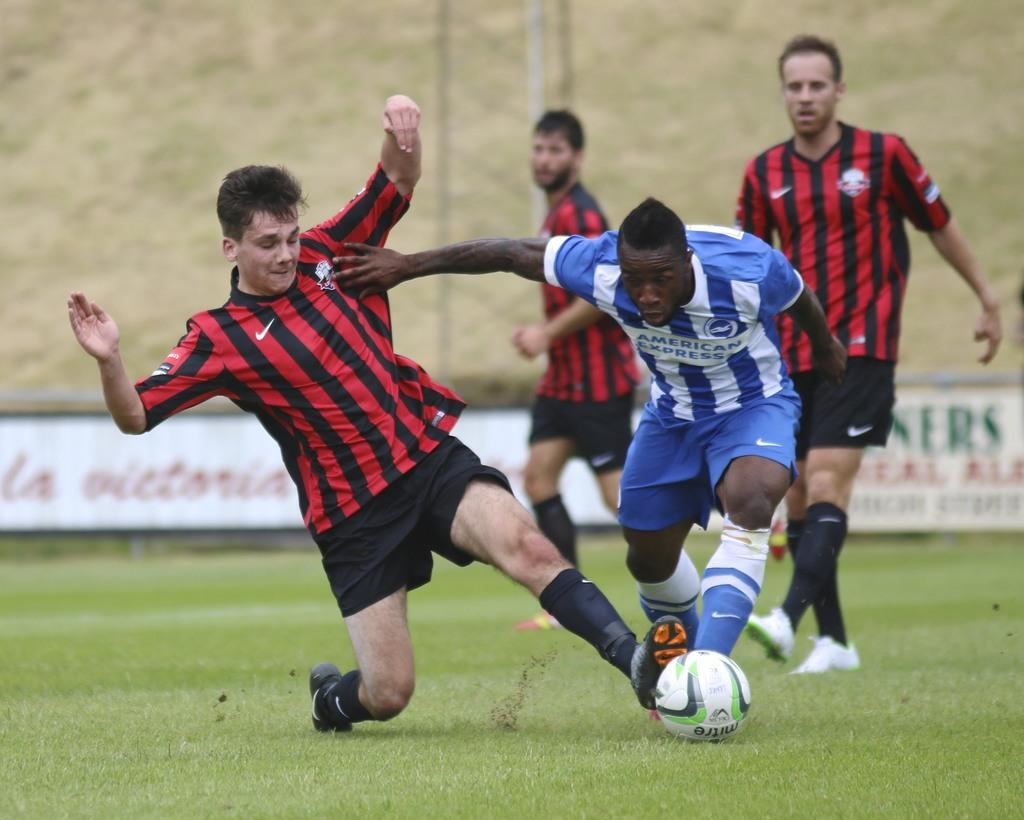How many people are present in the image? There are four people in the image. What are the people doing in the image? The people are playing a game with a ball. On what surface is the game being played? The game is being played on grass. Can you describe the background of the image? The background is blurred, but there is a pole and a banner visible. What type of birds can be seen flying in the image? There are no birds visible in the image; it features four people playing a game with a ball on grass. Where is the meeting taking place in the image? There is no meeting depicted in the image; it shows people playing a game with a ball on grass. 